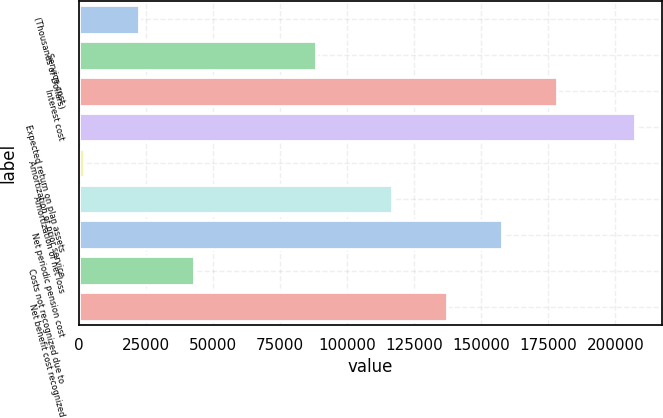Convert chart. <chart><loc_0><loc_0><loc_500><loc_500><bar_chart><fcel>(Thousands of Dollars)<fcel>Service cost<fcel>Interest cost<fcel>Expected return on plan assets<fcel>Amortization of prior service<fcel>Amortization of net loss<fcel>Net periodic pension cost<fcel>Costs not recognized due to<fcel>Net benefit cost recognized<nl><fcel>22291.9<fcel>88342<fcel>178400<fcel>207205<fcel>1746<fcel>116762<fcel>157854<fcel>42837.8<fcel>137308<nl></chart> 